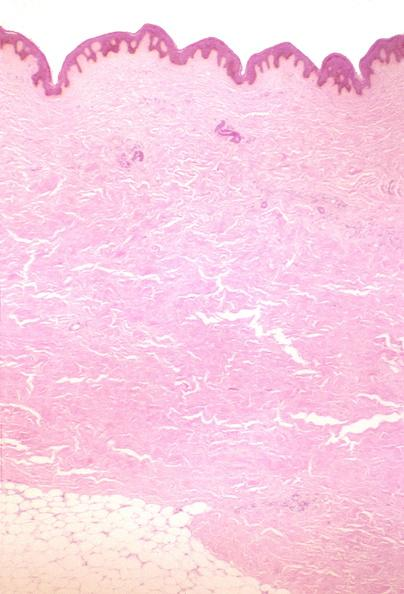does this image show scleroderma?
Answer the question using a single word or phrase. Yes 